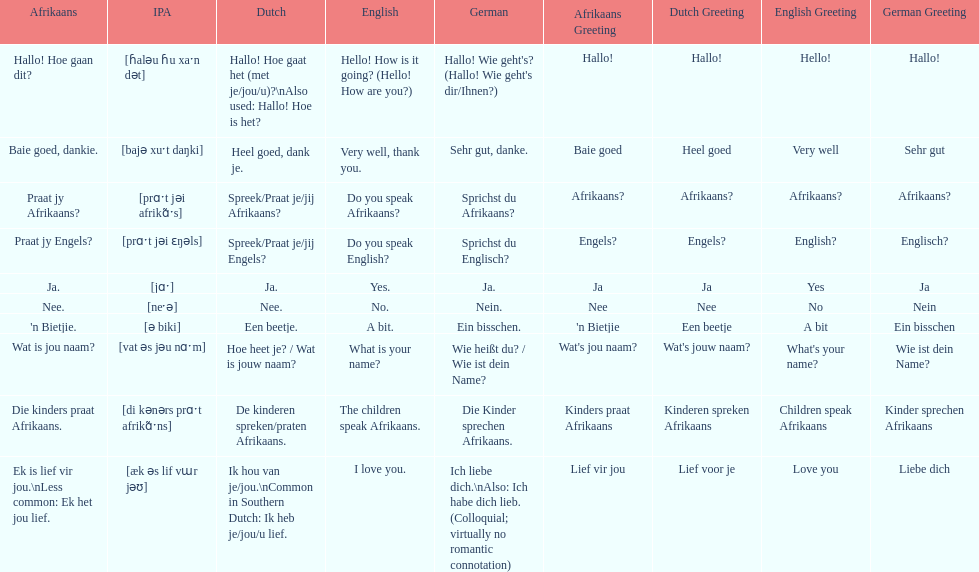How do you say 'i love you' in afrikaans? Ek is lief vir jou. 